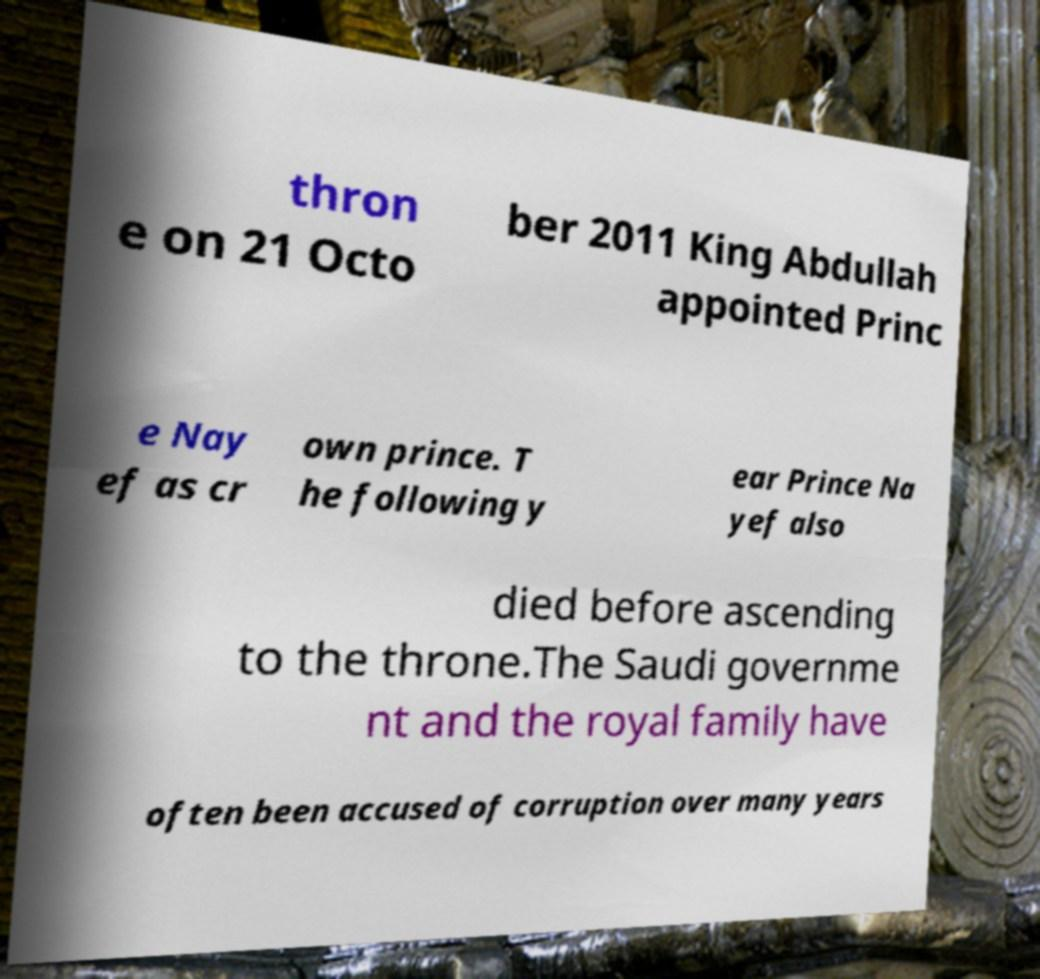I need the written content from this picture converted into text. Can you do that? thron e on 21 Octo ber 2011 King Abdullah appointed Princ e Nay ef as cr own prince. T he following y ear Prince Na yef also died before ascending to the throne.The Saudi governme nt and the royal family have often been accused of corruption over many years 